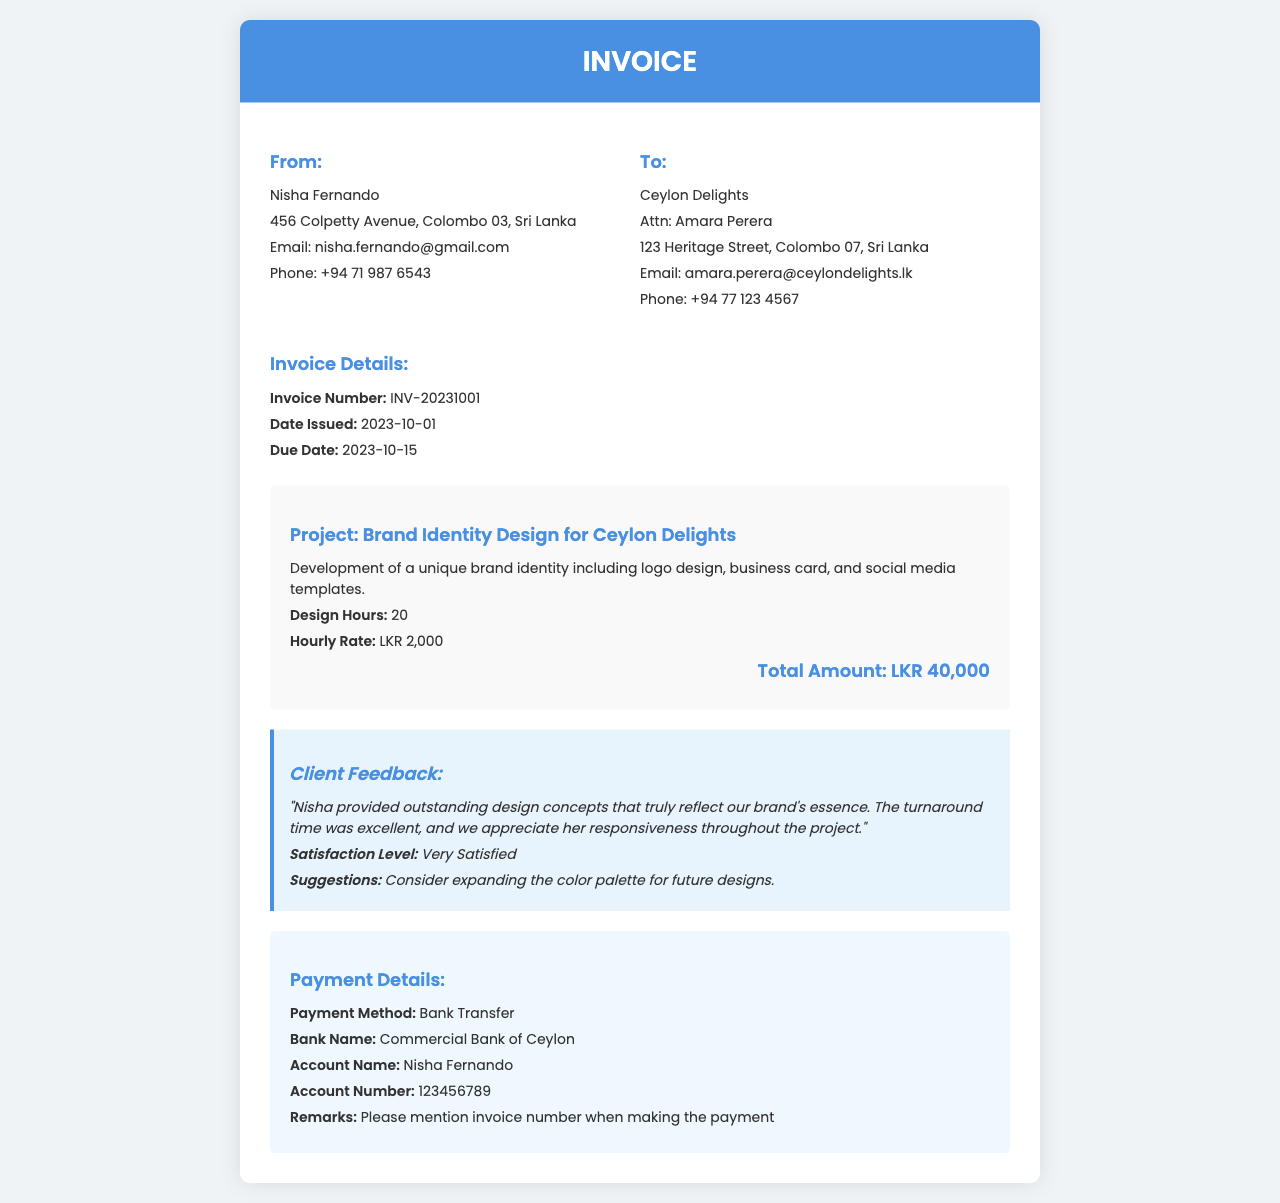what is the name of the freelancer? The freelancer's name is provided in the "From" section of the invoice.
Answer: Nisha Fernando what is the invoice number? The invoice number is explicitly mentioned in the document under "Invoice Details".
Answer: INV-20231001 what is the total amount due? The total amount is stated in the "project details" section.
Answer: LKR 40,000 how many design hours were worked? The number of design hours is specified in the "project details" section.
Answer: 20 what is the client's satisfaction level? The client's feedback provides a sentiment level regarding satisfaction.
Answer: Very Satisfied who is the client? The client’s name is listed in the "To" section of the invoice.
Answer: Ceylon Delights what is the due date for payment? The due date is mentioned in the "Invoice Details" section of the document.
Answer: 2023-10-15 what payment method is specified? The payment method is described in the "Payment Details" section of the invoice.
Answer: Bank Transfer what was the hourly rate for the design work? The hourly rate is outlined in the "project details" section.
Answer: LKR 2,000 